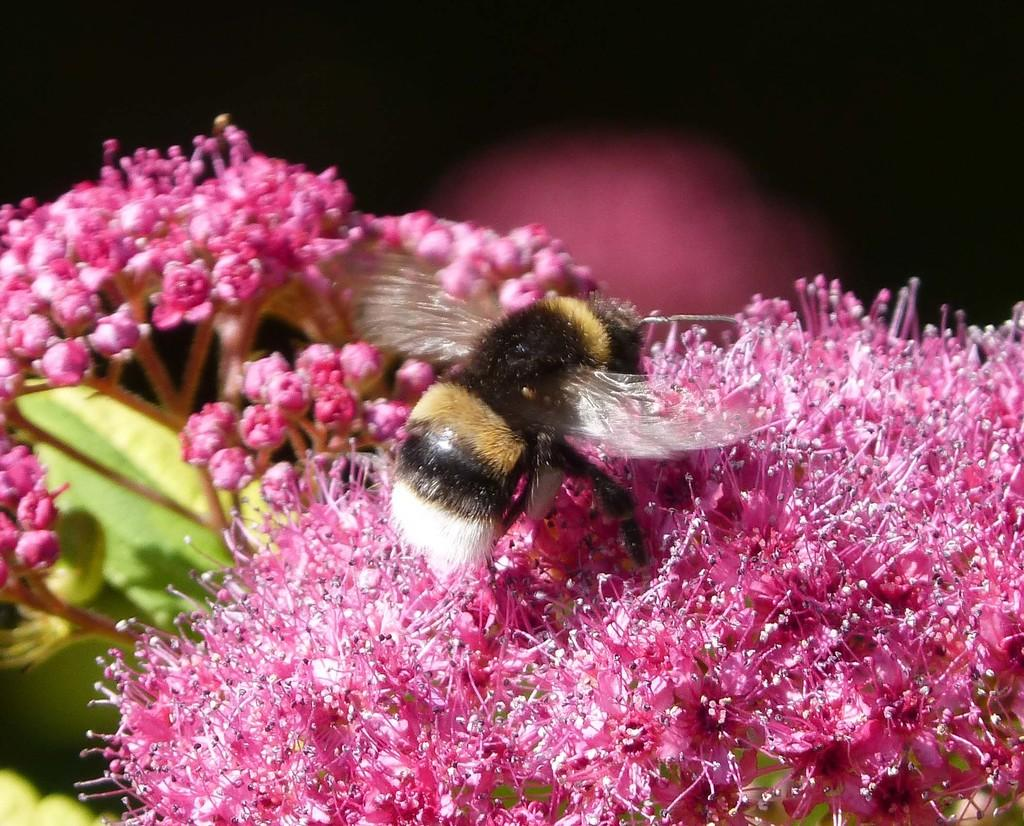What type of creature can be seen in the image? There is an insect in the image. What is the insect sitting on in the image? The insect is on pink color flowers. What type of answer can be seen in the image? There is no answer present in the image; it features an insect on pink color flowers. What type of birds can be seen in the image? There are no birds present in the image; it features an insect on pink color flowers. 